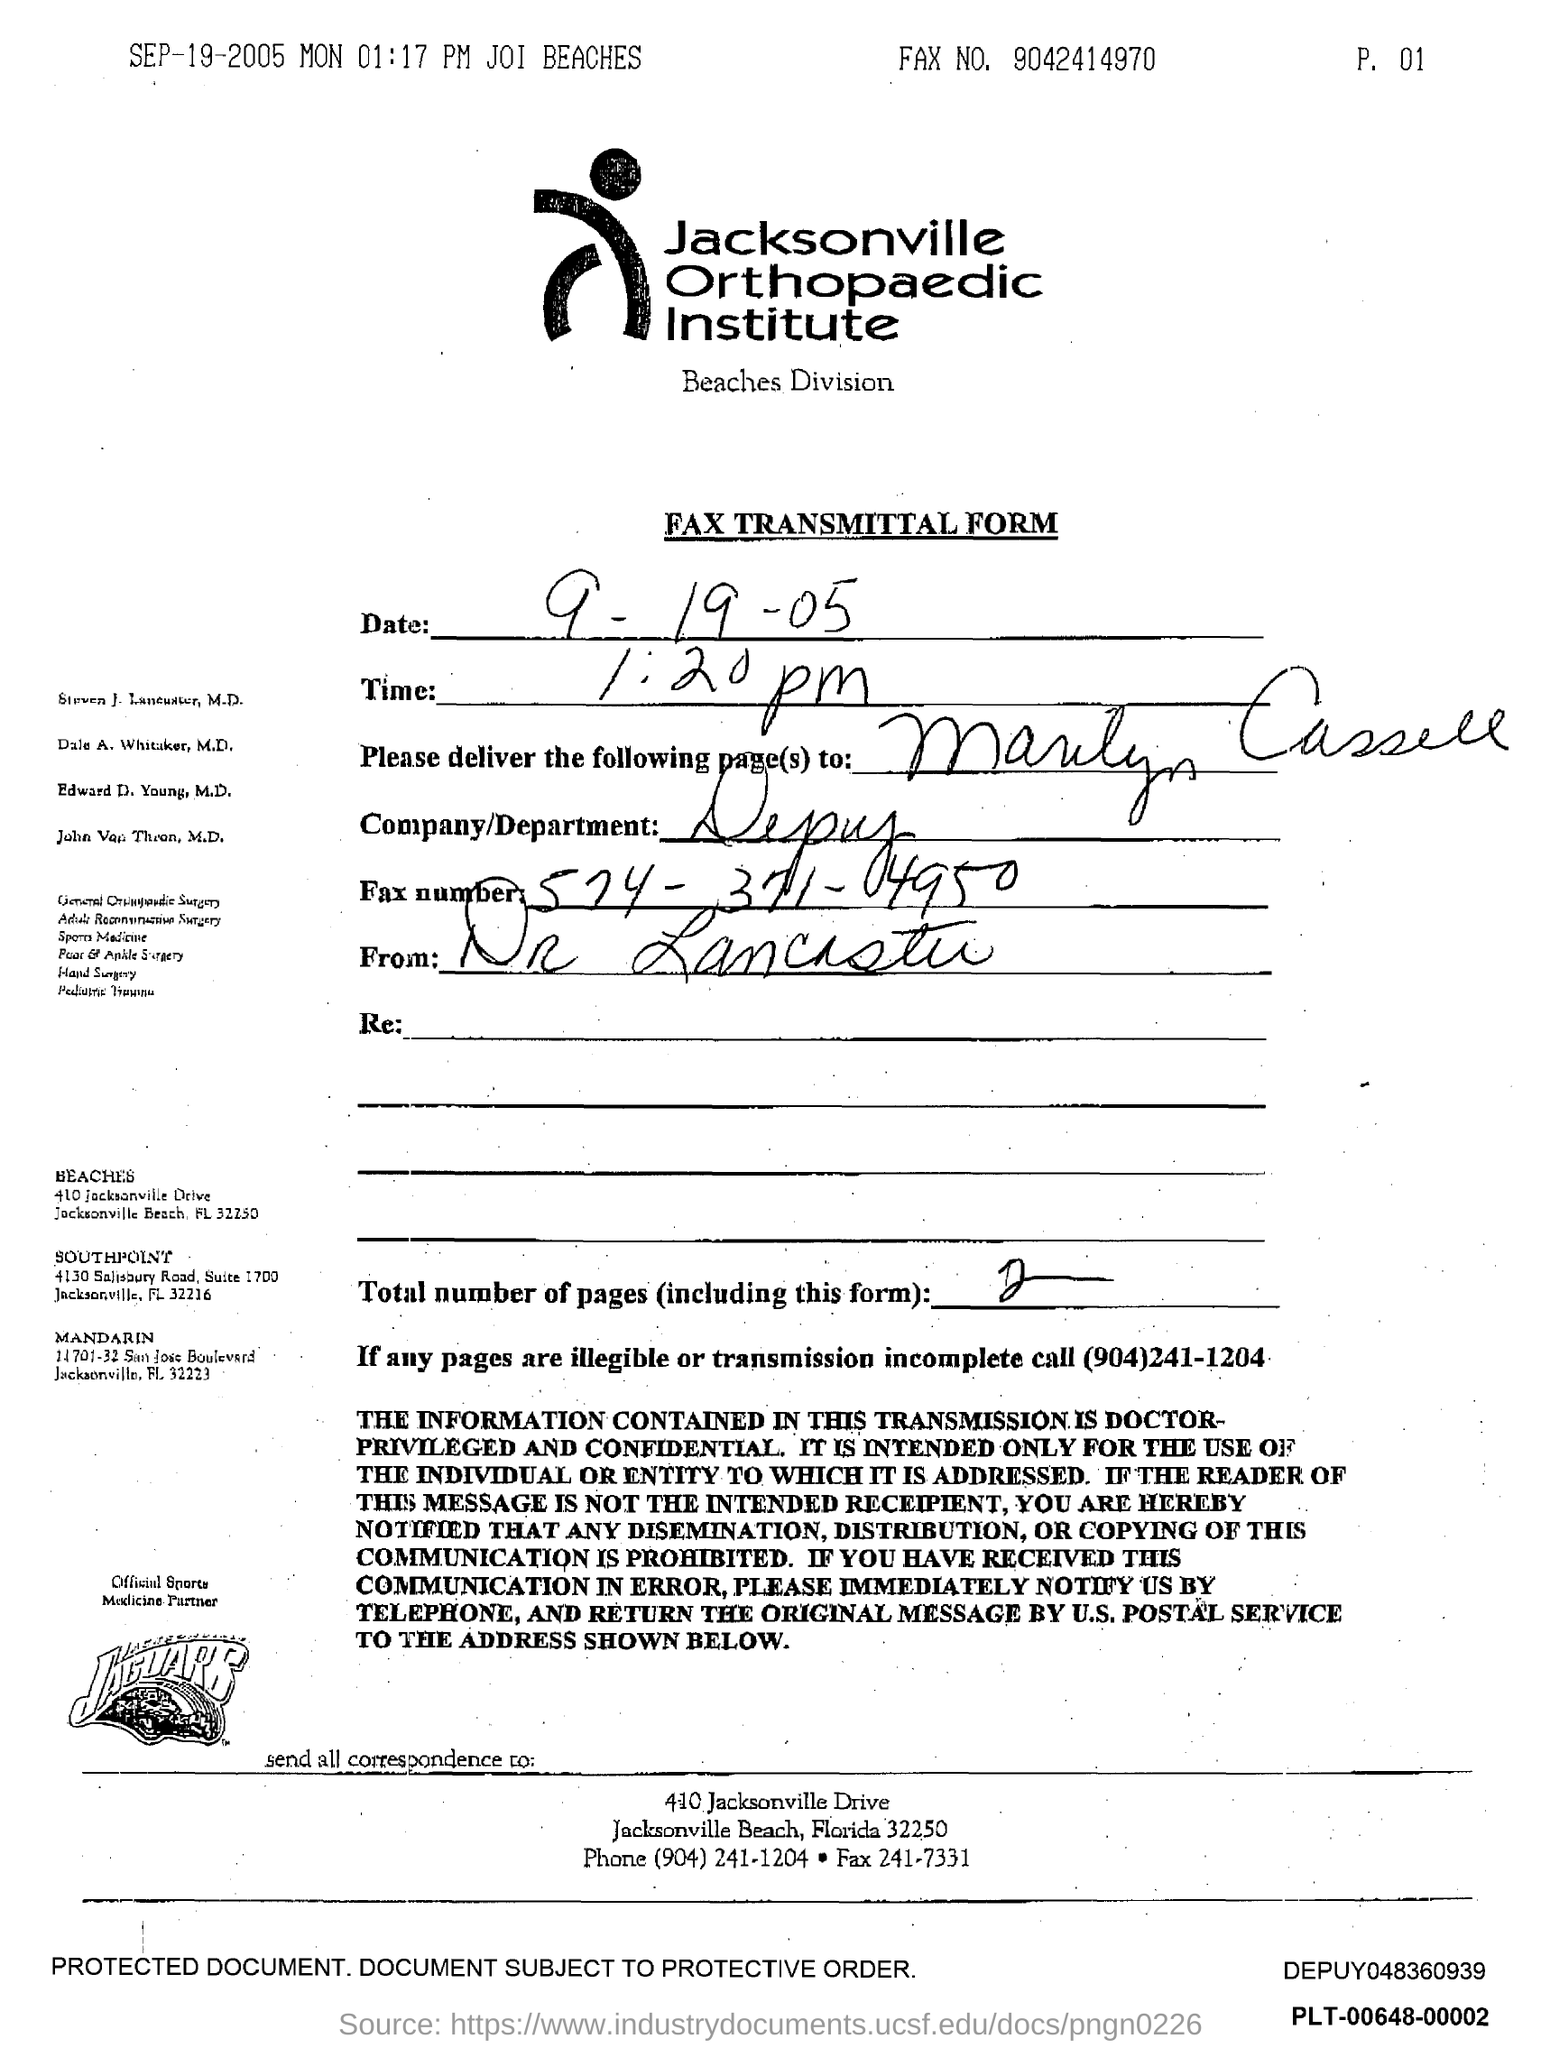Highlight a few significant elements in this photo. The company/department is Depuy. At 1:20 pm, it is currently time. If any pages are illegible or transmission is incomplete, the number to be called is (904)241-1204. 